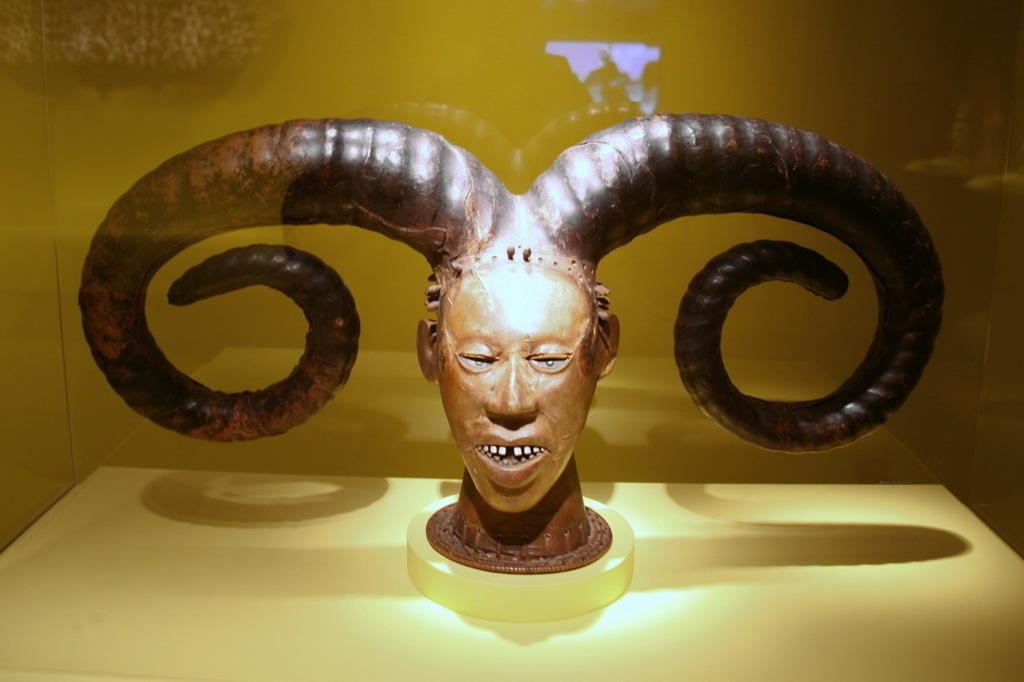What type of sculpture is in the image? There is a sculpture of a person's head in the image. What distinguishing feature does the sculpture have? The sculpture has two horns. Where is the sculpture located in relation to the mirror? The sculpture is behind the mirror. What type of cherry can be seen on the moon in the image? There is no cherry or moon present in the image; it features a sculpture of a person's head with two horns behind a mirror. 